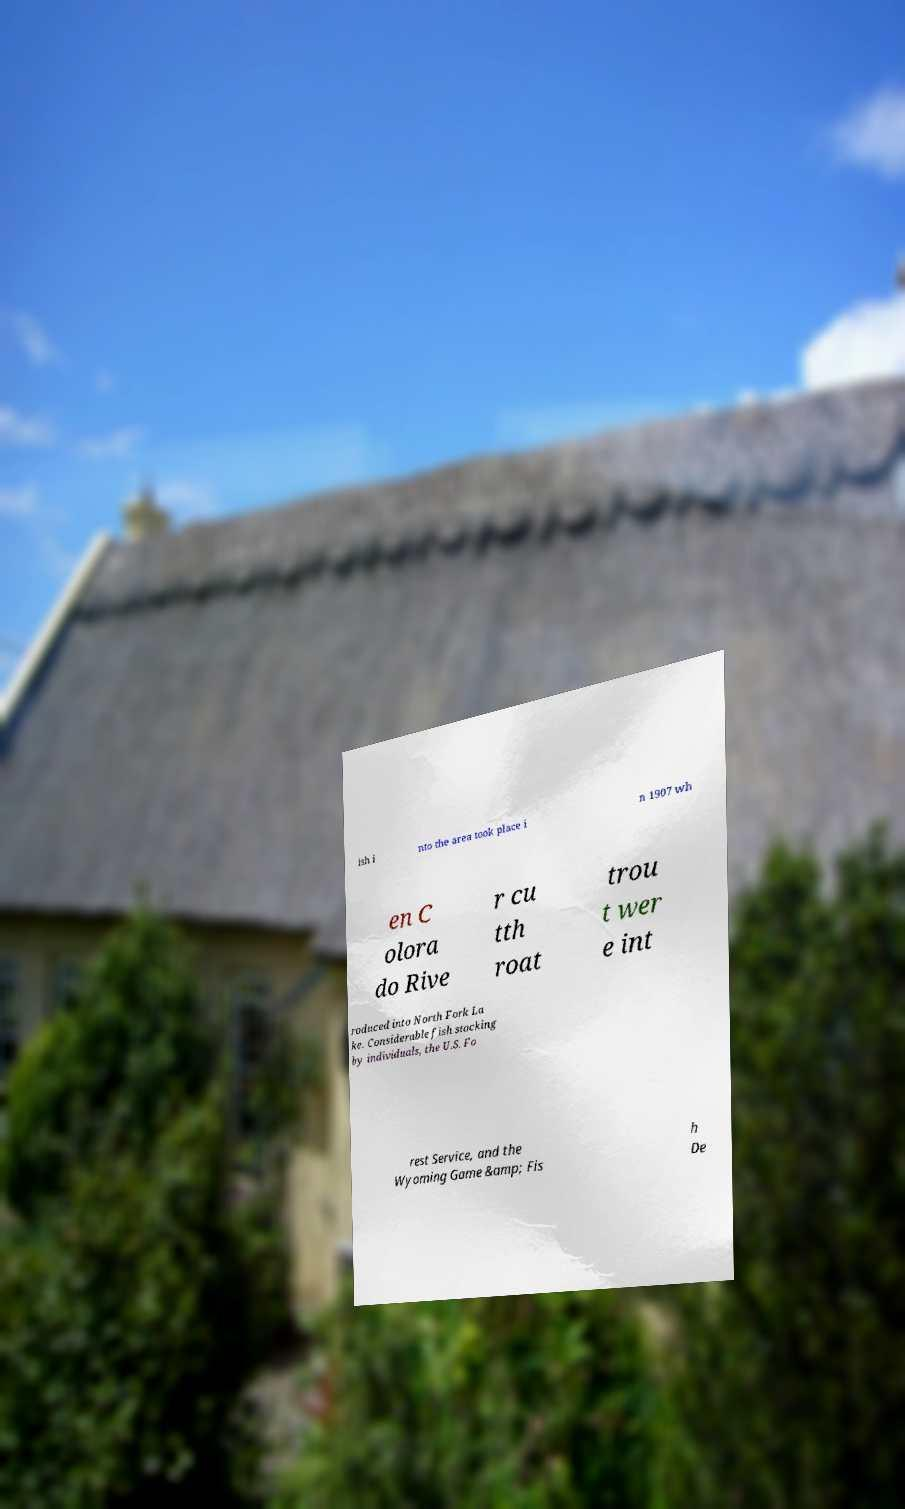Could you extract and type out the text from this image? ish i nto the area took place i n 1907 wh en C olora do Rive r cu tth roat trou t wer e int roduced into North Fork La ke. Considerable fish stocking by individuals, the U.S. Fo rest Service, and the Wyoming Game &amp; Fis h De 